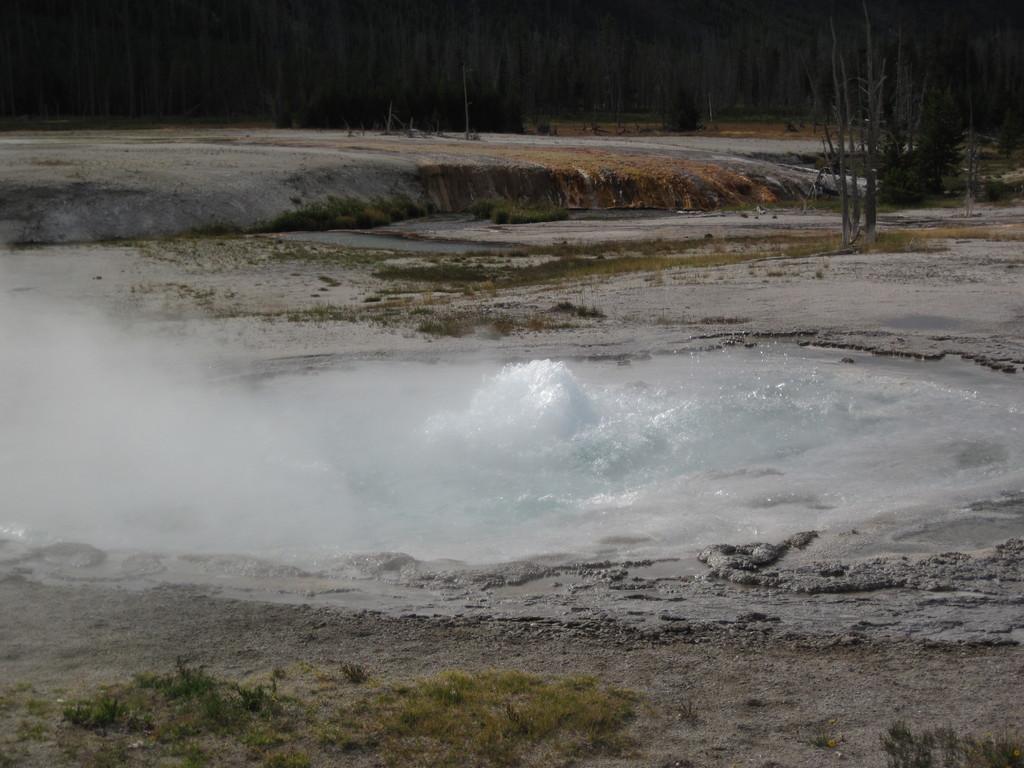Please provide a concise description of this image. Here we can see grass and water. In the background we can see dried trees and it is dark. 